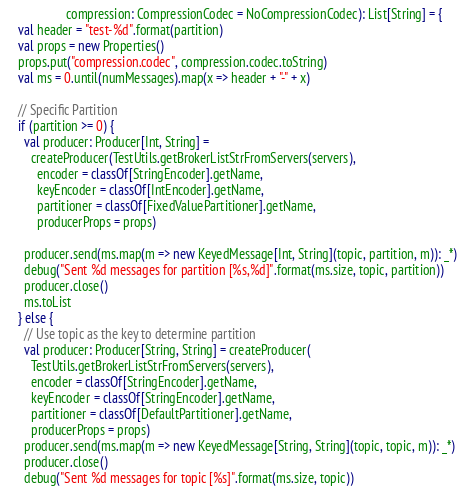<code> <loc_0><loc_0><loc_500><loc_500><_Scala_>                   compression: CompressionCodec = NoCompressionCodec): List[String] = {
    val header = "test-%d".format(partition)
    val props = new Properties()
    props.put("compression.codec", compression.codec.toString)
    val ms = 0.until(numMessages).map(x => header + "-" + x)

    // Specific Partition
    if (partition >= 0) {
      val producer: Producer[Int, String] =
        createProducer(TestUtils.getBrokerListStrFromServers(servers),
          encoder = classOf[StringEncoder].getName,
          keyEncoder = classOf[IntEncoder].getName,
          partitioner = classOf[FixedValuePartitioner].getName,
          producerProps = props)

      producer.send(ms.map(m => new KeyedMessage[Int, String](topic, partition, m)): _*)
      debug("Sent %d messages for partition [%s,%d]".format(ms.size, topic, partition))
      producer.close()
      ms.toList
    } else {
      // Use topic as the key to determine partition
      val producer: Producer[String, String] = createProducer(
        TestUtils.getBrokerListStrFromServers(servers),
        encoder = classOf[StringEncoder].getName,
        keyEncoder = classOf[StringEncoder].getName,
        partitioner = classOf[DefaultPartitioner].getName,
        producerProps = props)
      producer.send(ms.map(m => new KeyedMessage[String, String](topic, topic, m)): _*)
      producer.close()
      debug("Sent %d messages for topic [%s]".format(ms.size, topic))</code> 